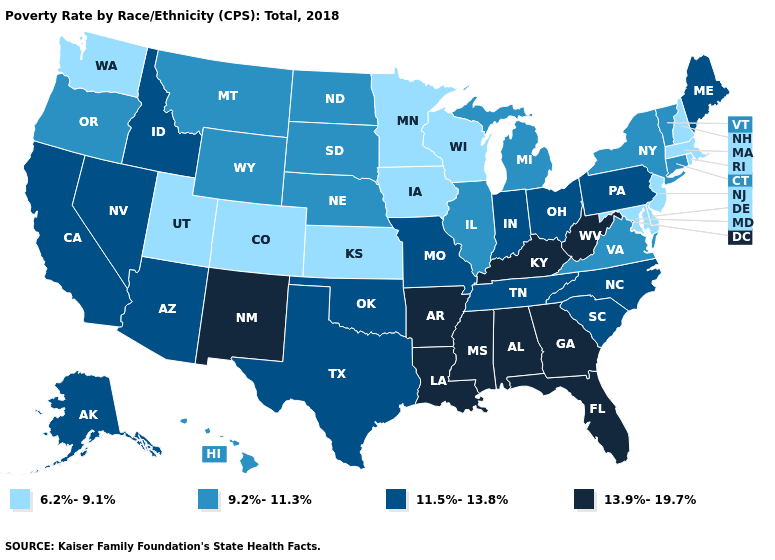What is the value of Idaho?
Give a very brief answer. 11.5%-13.8%. Which states hav the highest value in the West?
Answer briefly. New Mexico. Among the states that border Oregon , which have the highest value?
Quick response, please. California, Idaho, Nevada. Does South Carolina have the same value as California?
Write a very short answer. Yes. Is the legend a continuous bar?
Concise answer only. No. Name the states that have a value in the range 9.2%-11.3%?
Give a very brief answer. Connecticut, Hawaii, Illinois, Michigan, Montana, Nebraska, New York, North Dakota, Oregon, South Dakota, Vermont, Virginia, Wyoming. Name the states that have a value in the range 6.2%-9.1%?
Short answer required. Colorado, Delaware, Iowa, Kansas, Maryland, Massachusetts, Minnesota, New Hampshire, New Jersey, Rhode Island, Utah, Washington, Wisconsin. Which states have the lowest value in the South?
Answer briefly. Delaware, Maryland. Does Kentucky have a higher value than West Virginia?
Keep it brief. No. Among the states that border Arizona , does Utah have the lowest value?
Quick response, please. Yes. Does Montana have the lowest value in the West?
Give a very brief answer. No. Does the map have missing data?
Write a very short answer. No. What is the value of Oklahoma?
Quick response, please. 11.5%-13.8%. Does Iowa have a higher value than South Dakota?
Write a very short answer. No. Name the states that have a value in the range 6.2%-9.1%?
Be succinct. Colorado, Delaware, Iowa, Kansas, Maryland, Massachusetts, Minnesota, New Hampshire, New Jersey, Rhode Island, Utah, Washington, Wisconsin. 